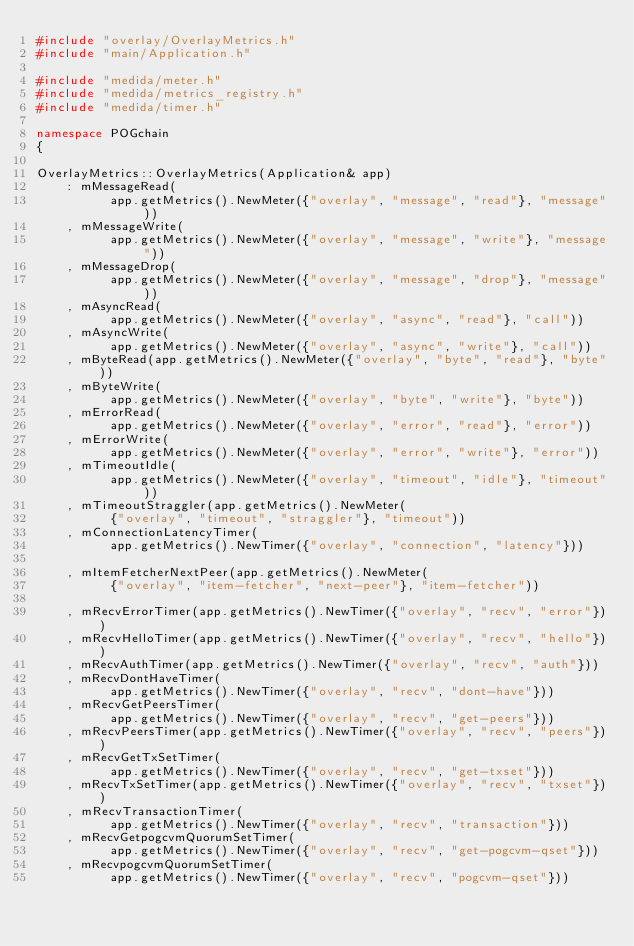<code> <loc_0><loc_0><loc_500><loc_500><_C++_>#include "overlay/OverlayMetrics.h"
#include "main/Application.h"

#include "medida/meter.h"
#include "medida/metrics_registry.h"
#include "medida/timer.h"

namespace POGchain
{

OverlayMetrics::OverlayMetrics(Application& app)
    : mMessageRead(
          app.getMetrics().NewMeter({"overlay", "message", "read"}, "message"))
    , mMessageWrite(
          app.getMetrics().NewMeter({"overlay", "message", "write"}, "message"))
    , mMessageDrop(
          app.getMetrics().NewMeter({"overlay", "message", "drop"}, "message"))
    , mAsyncRead(
          app.getMetrics().NewMeter({"overlay", "async", "read"}, "call"))
    , mAsyncWrite(
          app.getMetrics().NewMeter({"overlay", "async", "write"}, "call"))
    , mByteRead(app.getMetrics().NewMeter({"overlay", "byte", "read"}, "byte"))
    , mByteWrite(
          app.getMetrics().NewMeter({"overlay", "byte", "write"}, "byte"))
    , mErrorRead(
          app.getMetrics().NewMeter({"overlay", "error", "read"}, "error"))
    , mErrorWrite(
          app.getMetrics().NewMeter({"overlay", "error", "write"}, "error"))
    , mTimeoutIdle(
          app.getMetrics().NewMeter({"overlay", "timeout", "idle"}, "timeout"))
    , mTimeoutStraggler(app.getMetrics().NewMeter(
          {"overlay", "timeout", "straggler"}, "timeout"))
    , mConnectionLatencyTimer(
          app.getMetrics().NewTimer({"overlay", "connection", "latency"}))

    , mItemFetcherNextPeer(app.getMetrics().NewMeter(
          {"overlay", "item-fetcher", "next-peer"}, "item-fetcher"))

    , mRecvErrorTimer(app.getMetrics().NewTimer({"overlay", "recv", "error"}))
    , mRecvHelloTimer(app.getMetrics().NewTimer({"overlay", "recv", "hello"}))
    , mRecvAuthTimer(app.getMetrics().NewTimer({"overlay", "recv", "auth"}))
    , mRecvDontHaveTimer(
          app.getMetrics().NewTimer({"overlay", "recv", "dont-have"}))
    , mRecvGetPeersTimer(
          app.getMetrics().NewTimer({"overlay", "recv", "get-peers"}))
    , mRecvPeersTimer(app.getMetrics().NewTimer({"overlay", "recv", "peers"}))
    , mRecvGetTxSetTimer(
          app.getMetrics().NewTimer({"overlay", "recv", "get-txset"}))
    , mRecvTxSetTimer(app.getMetrics().NewTimer({"overlay", "recv", "txset"}))
    , mRecvTransactionTimer(
          app.getMetrics().NewTimer({"overlay", "recv", "transaction"}))
    , mRecvGetpogcvmQuorumSetTimer(
          app.getMetrics().NewTimer({"overlay", "recv", "get-pogcvm-qset"}))
    , mRecvpogcvmQuorumSetTimer(
          app.getMetrics().NewTimer({"overlay", "recv", "pogcvm-qset"}))</code> 